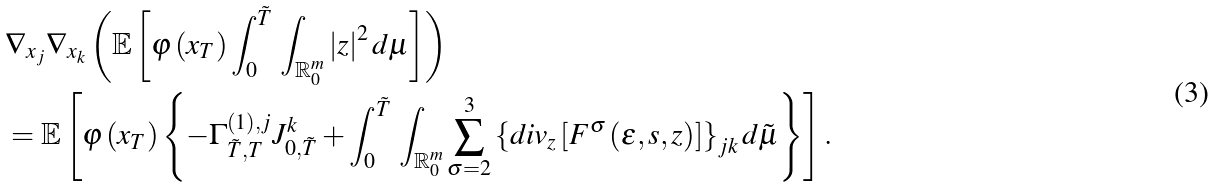<formula> <loc_0><loc_0><loc_500><loc_500>& \nabla _ { x _ { j } } \nabla _ { x _ { k } } \left ( \mathbb { E } \left [ \varphi \left ( x _ { T } \right ) \int _ { 0 } ^ { \tilde { T } } \, \int _ { \mathbb { R } _ { 0 } ^ { m } } \left | z \right | ^ { 2 } d \mu \right ] \right ) \\ & = \mathbb { E } \left [ \varphi \left ( x _ { T } \right ) \left \{ - \Gamma _ { \tilde { T } , T } ^ { \left ( 1 \right ) , j } J _ { 0 , \tilde { T } } ^ { k } + \int _ { 0 } ^ { \tilde { T } } \, \int _ { \mathbb { R } _ { 0 } ^ { m } } \sum _ { \sigma = 2 } ^ { 3 } \left \{ d i v _ { z } \left [ F ^ { \sigma } \left ( \varepsilon , s , z \right ) \right ] \right \} _ { j k } d \tilde { \mu } \right \} \right ] .</formula> 